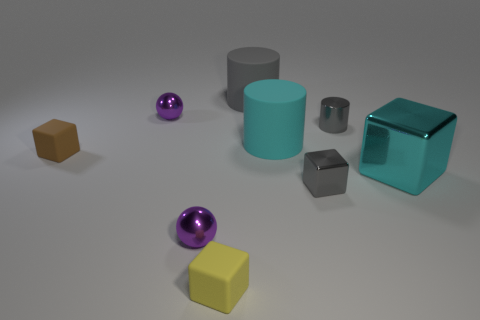How are the objects arranged in the image? The objects are spaced out across the surface, with no discernible pattern. Their arrangement appears random, with varying distances between them which could evoke a sense of calm disarray or a study of different shapes and sizes. 